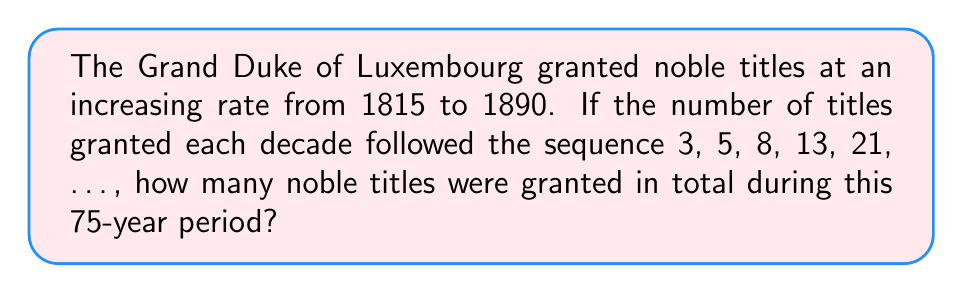Provide a solution to this math problem. Let's approach this step-by-step:

1) First, we need to recognize the sequence. This is a Fibonacci sequence where each term is the sum of the two preceding ones.

2) We need to determine how many terms we need. Since the period is 75 years and each term represents a decade, we need 8 terms (75 ÷ 10 = 7.5, rounded up to 8).

3) Let's list out the 8 terms of the sequence:
   3, 5, 8, 13, 21, 34, 55, 89

4) To find the total number of titles granted, we need to sum these terms:

   $$ S = 3 + 5 + 8 + 13 + 21 + 34 + 55 + 89 $$

5) We can use the formula for the sum of Fibonacci numbers:
   
   $$ S_n = F_{n+2} - 1 $$

   Where $S_n$ is the sum of the first n Fibonacci numbers, and $F_n$ is the nth Fibonacci number.

6) In our case, n = 8, so we need to find $F_{10}$:
   
   $$ F_9 = 34, F_{10} = 55, F_{11} = 89, F_{12} = 144 $$

7) Therefore, the sum is:

   $$ S_8 = F_{10} - 1 = 144 - 1 = 228 $$

Thus, 228 noble titles were granted in total during this 75-year period.
Answer: 228 